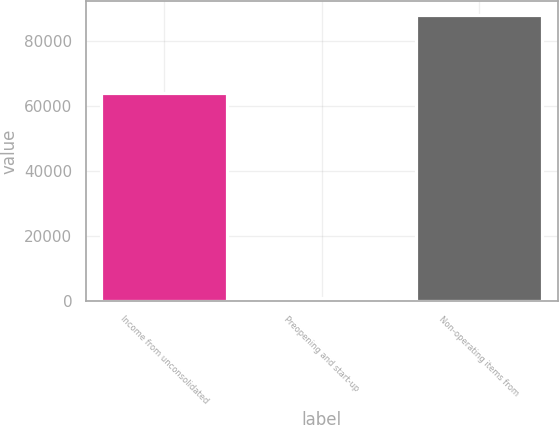Convert chart. <chart><loc_0><loc_0><loc_500><loc_500><bar_chart><fcel>Income from unconsolidated<fcel>Preopening and start-up<fcel>Non-operating items from<nl><fcel>63836<fcel>917<fcel>87794<nl></chart> 